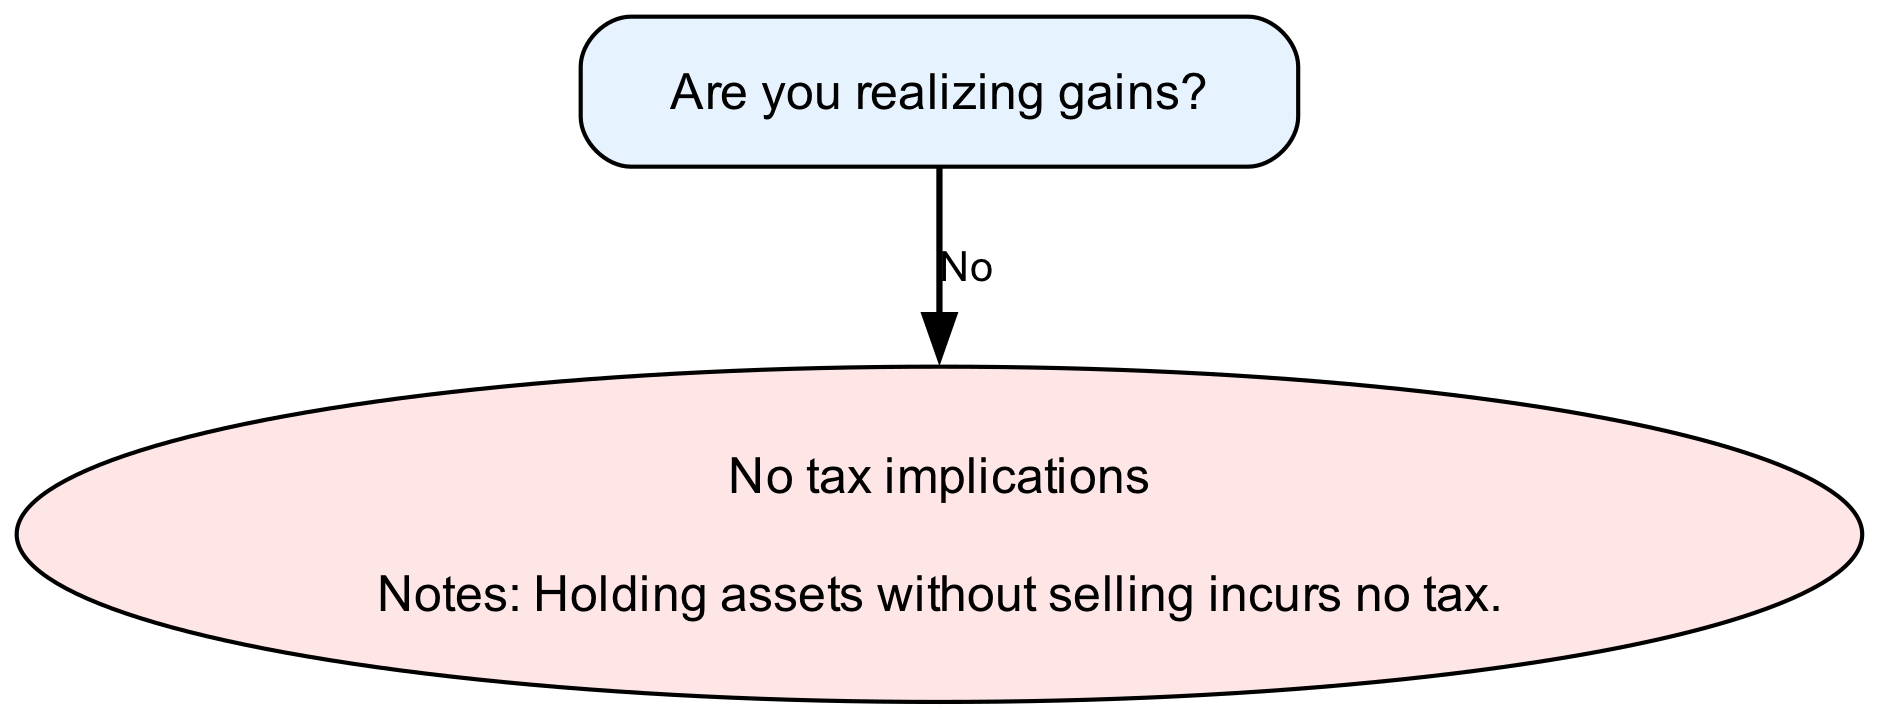Are you realizing gains? The first question in the decision tree asks whether gains are being realized. It is the initial decision point in the diagram. If the answer is "Yes," it leads to further questions regarding the source of the gains; if "No," it leads to the outcome stating there are no tax implications.
Answer: Yes Is the gain from Real Estate or Cryptocurrency? This question follows the initial decision and specifically categorizes the source of the realized gains into either Real Estate or Cryptocurrency. It determines the path to take for the ensuing decisions and outcomes.
Answer: Real Estate Was the property held for over a year? After selecting Real Estate, this question evaluates the duration the property was held. The answer leads to different tax implications: long-term or short-term capital gains.
Answer: Yes What is the outcome if cryptocurrency was held for over a year? This question requires following the path starting with the decision "Is the gain from Cryptocurrency?" If the answer to the subsequent question about the holding period is "Yes," the outcome indicates that it is taxed at the long-term capital gains rate.
Answer: Taxed at long-term capital gains rate What are the notes associated with the outcome for short-term capital gains from Real Estate? This question probes into the specific notes attached to the outcome of short-term capital gains after determining the property was held for less than a year. The notes clarify how these gains are taxed and imply that they are taxed like ordinary income.
Answer: Same as ordinary income tax rate What denotes the outcome when there are no realized gains? Following the initial decision of realizing gains or not, this question seeks to understand the implications when gains are not realized. According to the decision tree, it is clearly stated that holding assets without selling incurs no tax, leading to a specific outcome.
Answer: No tax implications What is the next decision after realizing gains from Cryptocurrency? This question investigates the path following the realization of gains specifically from Cryptocurrency. It requires identifying that the next decision is about whether the cryptocurrency was held for over a year, which determines taxation.
Answer: Was the cryptocurrency held for over a year? What notes are associated with long-term capital gains from cryptocurrency? This question examines the additional information that comes with the outcome of being taxed at the long-term capital gains rate for cryptocurrency, revealing that there could be variances in tax regulation depending on state laws.
Answer: Potentially subject to different regulations per state 